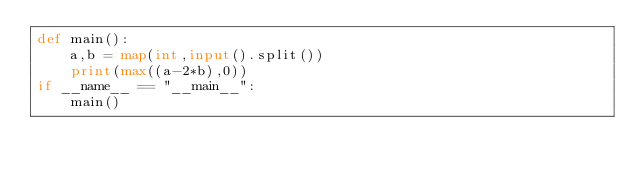Convert code to text. <code><loc_0><loc_0><loc_500><loc_500><_Python_>def main():
    a,b = map(int,input().split())
    print(max((a-2*b),0))
if __name__ == "__main__":
    main()</code> 